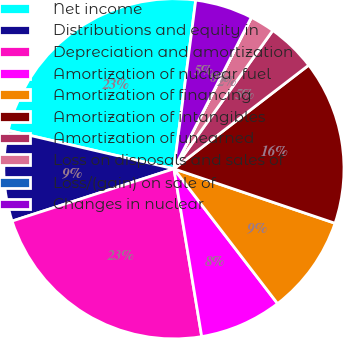Convert chart. <chart><loc_0><loc_0><loc_500><loc_500><pie_chart><fcel>Net income<fcel>Distributions and equity in<fcel>Depreciation and amortization<fcel>Amortization of nuclear fuel<fcel>Amortization of financing<fcel>Amortization of intangibles<fcel>Amortization of unearned<fcel>Loss on disposals and sales of<fcel>Loss/(gain) on sale of<fcel>Changes in nuclear<nl><fcel>23.42%<fcel>8.6%<fcel>22.64%<fcel>7.82%<fcel>9.38%<fcel>15.62%<fcel>4.69%<fcel>2.35%<fcel>0.01%<fcel>5.47%<nl></chart> 